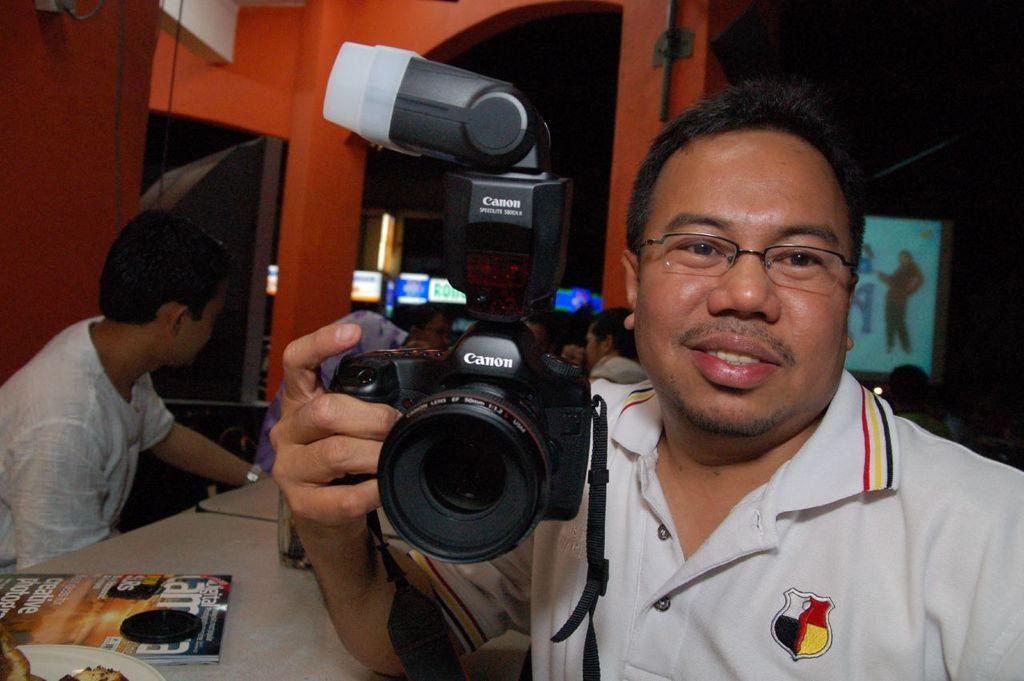Please provide a concise description of this image. In this image there are group of people, this person in the front is holding a camera with a name canon and is leaning on a table, magazine is kept on the table. At the left side person wearing a white shirt is seeing in front. In the background there is a frame with a woman photo standing and some sign boards and a wall. 